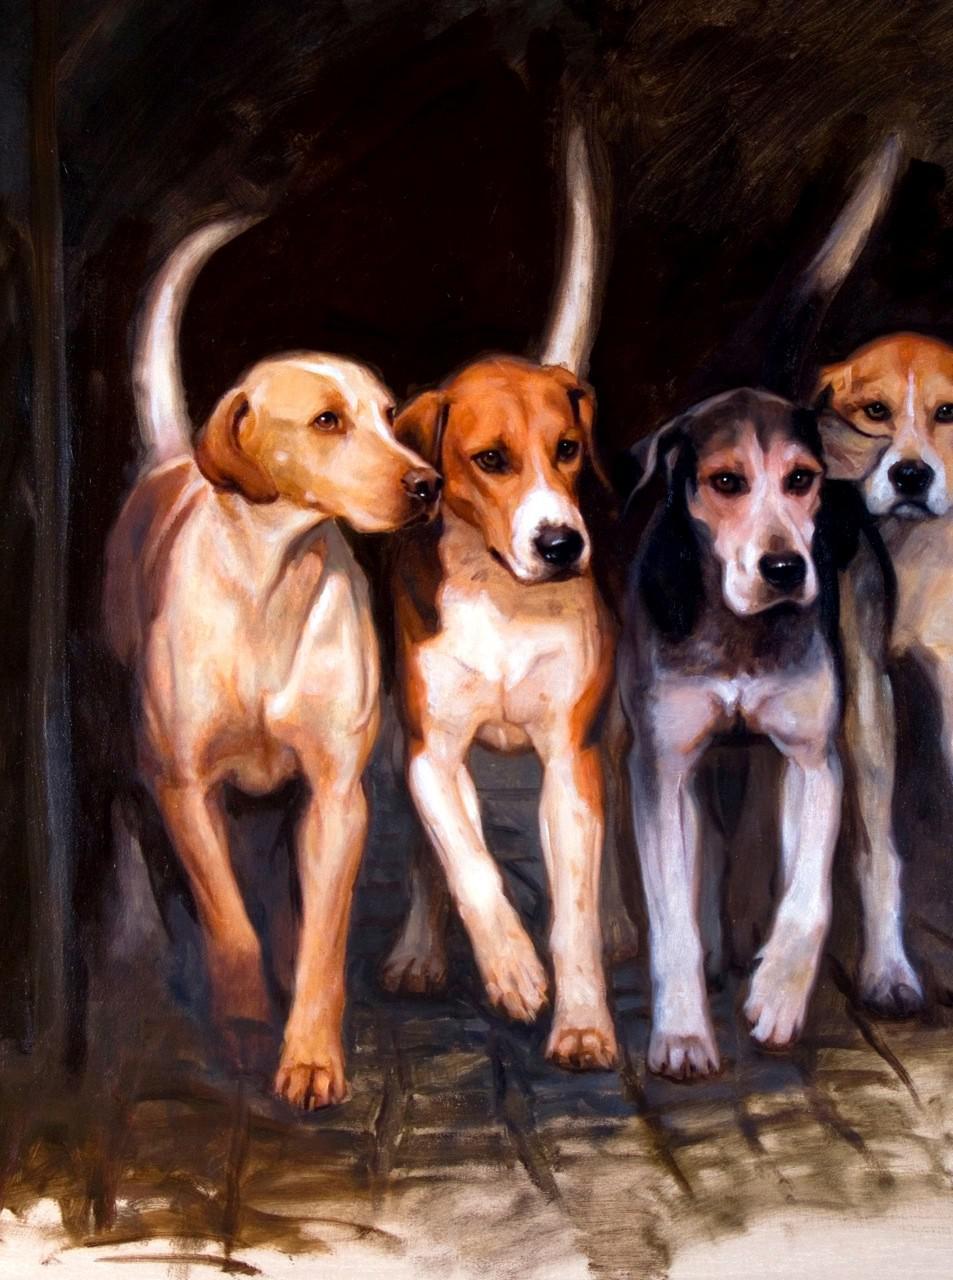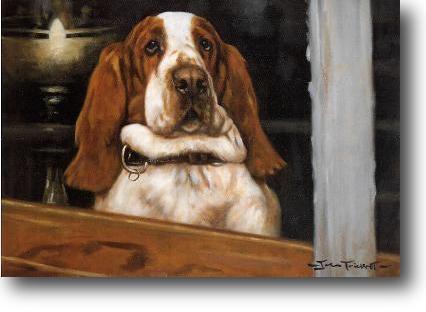The first image is the image on the left, the second image is the image on the right. Analyze the images presented: Is the assertion "One image shows multiple dogs moving forward, and the other image shows a single camera-facing hound." valid? Answer yes or no. Yes. 